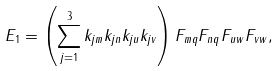Convert formula to latex. <formula><loc_0><loc_0><loc_500><loc_500>E _ { 1 } = \left ( \sum _ { j = 1 } ^ { 3 } k _ { j m } k _ { j n } k _ { j u } k _ { j v } \right ) F _ { m q } F _ { n q } F _ { u w } F _ { v w } ,</formula> 